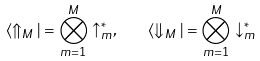Convert formula to latex. <formula><loc_0><loc_0><loc_500><loc_500>\langle \Uparrow _ { M } | = \bigotimes _ { m = 1 } ^ { M } \uparrow ^ { * } _ { m } , \quad \langle \Downarrow _ { M } | = \bigotimes _ { m = 1 } ^ { M } \downarrow ^ { * } _ { m }</formula> 